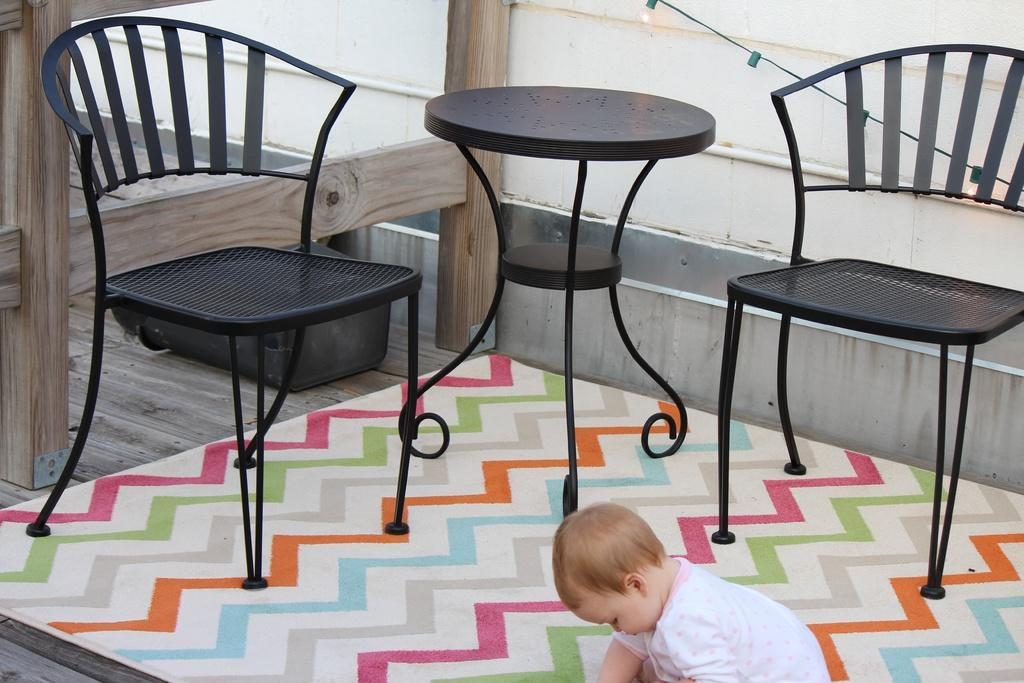How many chairs are in the image? There are two chairs in the image. What is the primary piece of furniture in the image? There is a table in the image. Who is present in the image? There is a kid in the image. What material are the wooden sticks made of? The wooden sticks are made of wood. What is on the floor in the image? There is an object on the floor in the image. What is the background of the image? There is a wall in the image. What type of lighting is present in the image? Serial lights are present in the image. What type of flesh can be seen on the chairs in the image? There is no flesh present on the chairs in the image; they are made of a different material. 